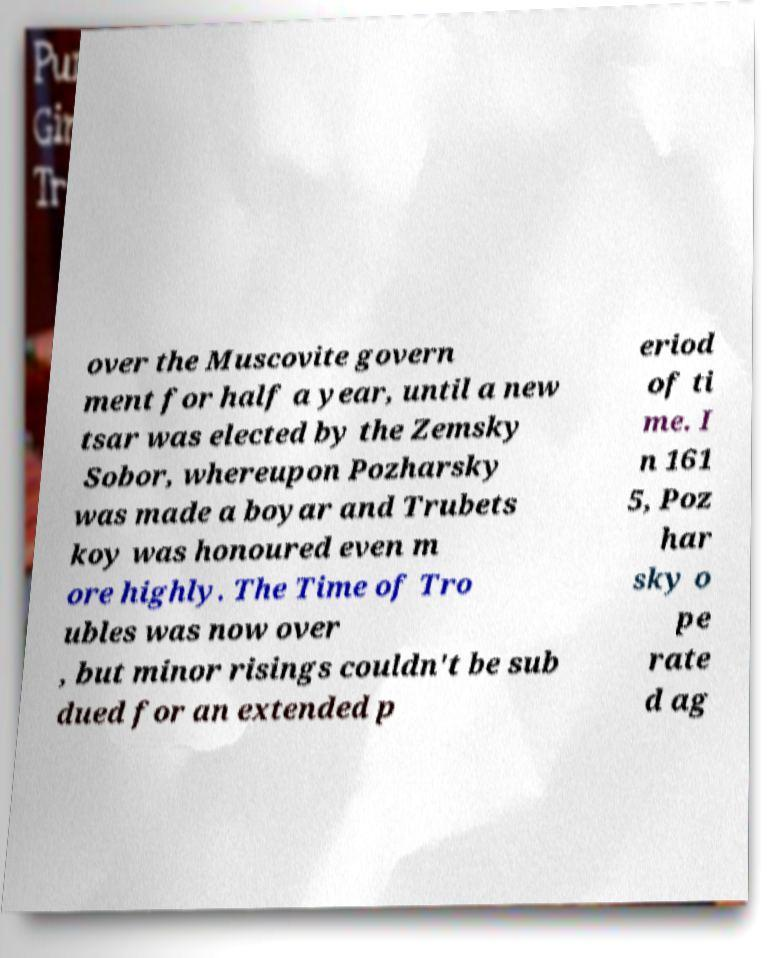Can you accurately transcribe the text from the provided image for me? over the Muscovite govern ment for half a year, until a new tsar was elected by the Zemsky Sobor, whereupon Pozharsky was made a boyar and Trubets koy was honoured even m ore highly. The Time of Tro ubles was now over , but minor risings couldn't be sub dued for an extended p eriod of ti me. I n 161 5, Poz har sky o pe rate d ag 